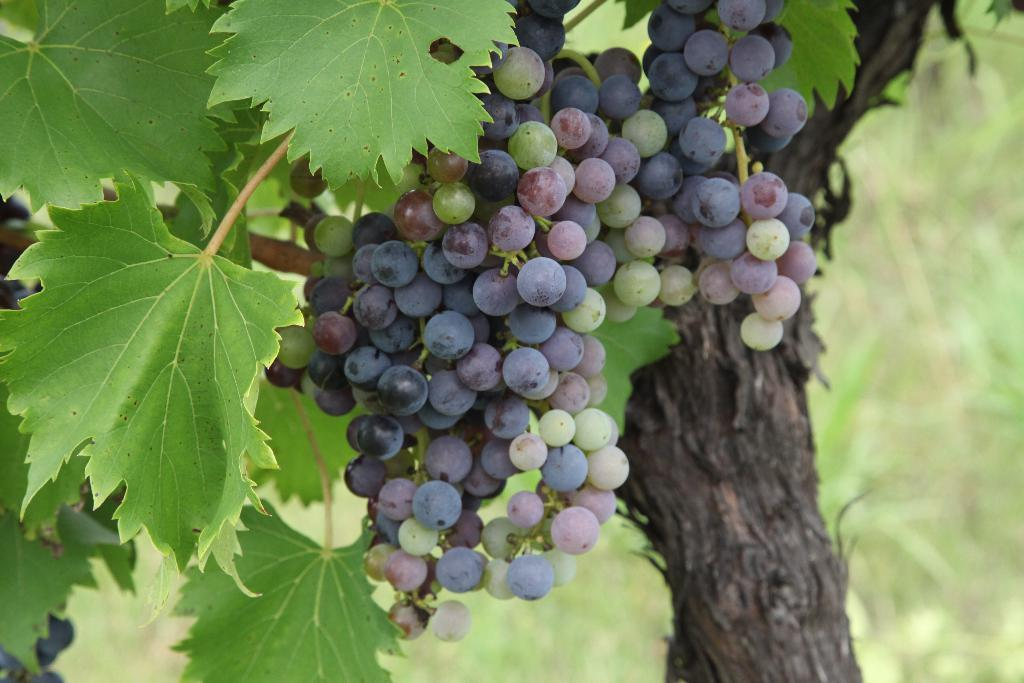What type of tree is present in the image? There is a tree with grapes in the image. What color are the grapes on the tree? The grapes are black in color. What can be seen in the background of the image? There are plants visible in the background of the image. What type of oatmeal is being served at the night event in the image? There is no oatmeal or night event present in the image; it features a tree with black grapes and plants in the background. 